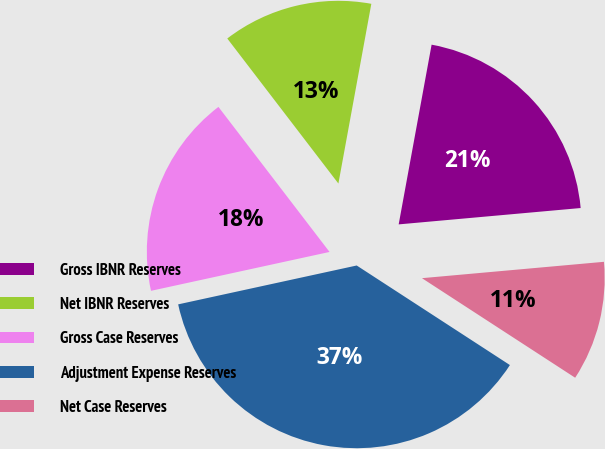Convert chart to OTSL. <chart><loc_0><loc_0><loc_500><loc_500><pie_chart><fcel>Gross IBNR Reserves<fcel>Net IBNR Reserves<fcel>Gross Case Reserves<fcel>Adjustment Expense Reserves<fcel>Net Case Reserves<nl><fcel>20.69%<fcel>13.29%<fcel>18.01%<fcel>37.42%<fcel>10.6%<nl></chart> 